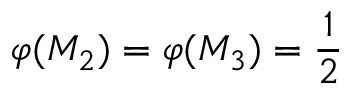Convert formula to latex. <formula><loc_0><loc_0><loc_500><loc_500>\varphi ( M _ { 2 } ) = \varphi ( M _ { 3 } ) = \frac { 1 } { 2 }</formula> 